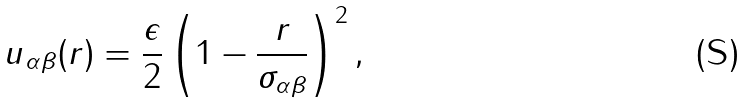Convert formula to latex. <formula><loc_0><loc_0><loc_500><loc_500>u _ { \alpha \beta } ( r ) = \frac { \epsilon } { 2 } \left ( 1 - \frac { r } { \sigma _ { \alpha \beta } } \right ) ^ { 2 } ,</formula> 